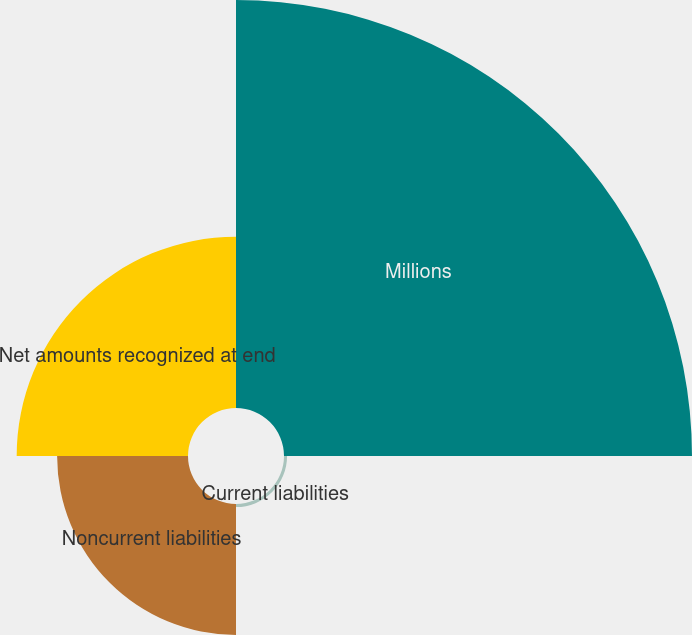<chart> <loc_0><loc_0><loc_500><loc_500><pie_chart><fcel>Millions<fcel>Current liabilities<fcel>Noncurrent liabilities<fcel>Net amounts recognized at end<nl><fcel>57.2%<fcel>0.43%<fcel>18.35%<fcel>24.02%<nl></chart> 